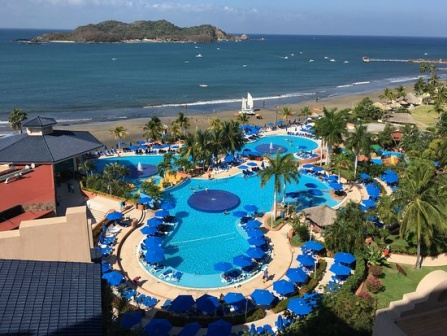Imagine a scenario where a treasure hunt is organized for children in this resort. Describe how it would be set up and the potential excitement it might generate. A treasure hunt at this vivid and lush resort would be a memorable adventure for children. The setup involves a series of cleverly hidden clues scattered throughout the resort grounds, beginning with a colorful treasure map handed out to each participant. The hunt starts by the poolside, where the first clue is cleverly hidden inside a floating waterproof box, encouraging the children to use their observational skills.

From there, the clues lead the children across various areas of the resort. One clue might be hidden under a lounge chair by the pool, another inside a bright blue umbrella when it’s closed. The clues are designed to guide the children to the beach, where they search for the next hint buried in the sand, perhaps inside a small, decorated bottle resembling messages in a bottle. 

As they follow each clue, they visit the garden near the resort buildings, where they might have to find a small flag or ornament particularly placed beneath a palm tree. The excitement will be palpable as children run from one location to another, working as a team, and feeling the thrill of discovery. The treasure itself could be hidden on the small island visible in the distance, making the final part of the hunt a short boat trip where they don life jackets and head towards the 'X' marks the spot. 

With every clue solved and each step closer to the treasure, children are not only engaged in a fun and stimulating activity but also creating indelible memories of their time at the resort. The excitement and joy of finding the final treasure, perhaps a box of small toys, trinkets, or a themed medal, would be the perfect culmination to an adventurous and delightful experience. 